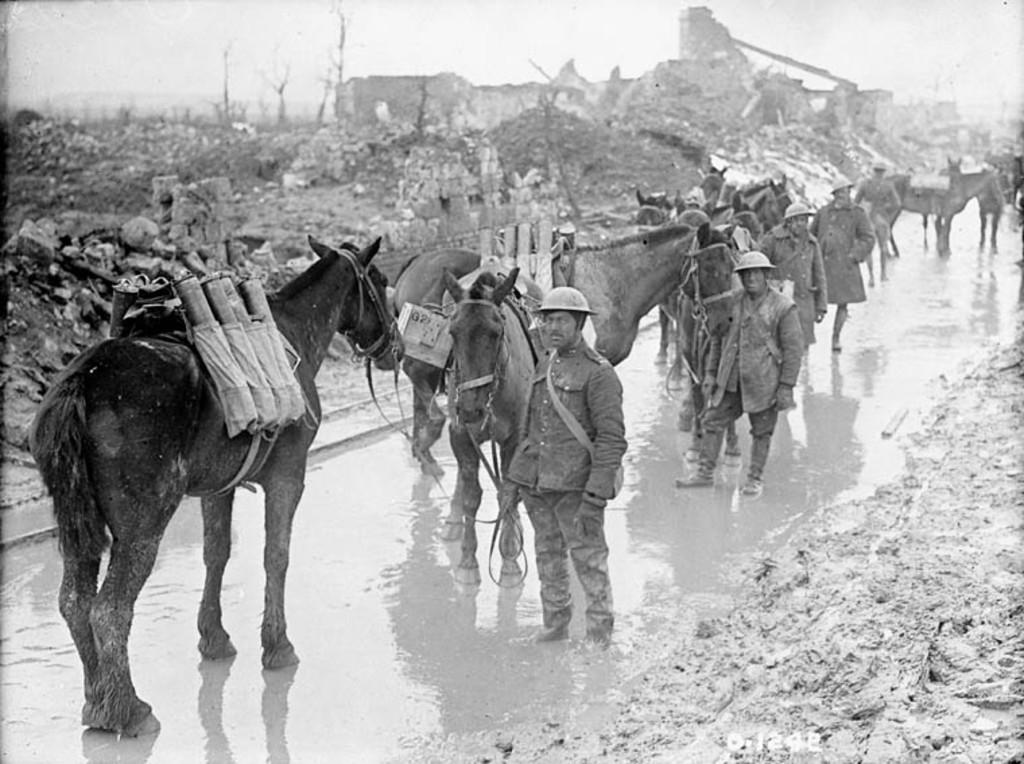What is the color scheme of the image? The image is black and white. What can be seen in the image besides the sky? There are persons standing beside a horse in the image. What is visible in the background of the image? The sky is visible in the background of the image. What type of toys can be seen in the image? There are no toys present in the image. How much payment is required to ride the horse in the image? There is no indication of payment or any transaction in the image. 